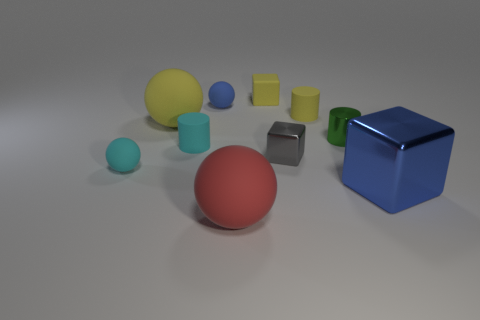There is a shiny object on the right side of the tiny green cylinder; what color is it?
Provide a short and direct response. Blue. Does the blue matte sphere have the same size as the cylinder on the left side of the big red object?
Your answer should be compact. Yes. What is the size of the cylinder that is both left of the shiny cylinder and to the right of the red rubber ball?
Your response must be concise. Small. Are there any large yellow objects that have the same material as the red sphere?
Make the answer very short. Yes. The big red rubber thing is what shape?
Ensure brevity in your answer.  Sphere. Do the yellow rubber cylinder and the yellow matte block have the same size?
Offer a very short reply. Yes. What number of other objects are the same shape as the gray shiny thing?
Give a very brief answer. 2. What shape is the blue thing on the left side of the large red matte sphere?
Provide a short and direct response. Sphere. There is a metallic thing in front of the tiny cyan matte ball; does it have the same shape as the blue thing behind the big blue metallic object?
Offer a terse response. No. Is the number of large red rubber objects that are behind the large blue object the same as the number of tiny gray rubber cubes?
Your answer should be very brief. Yes. 